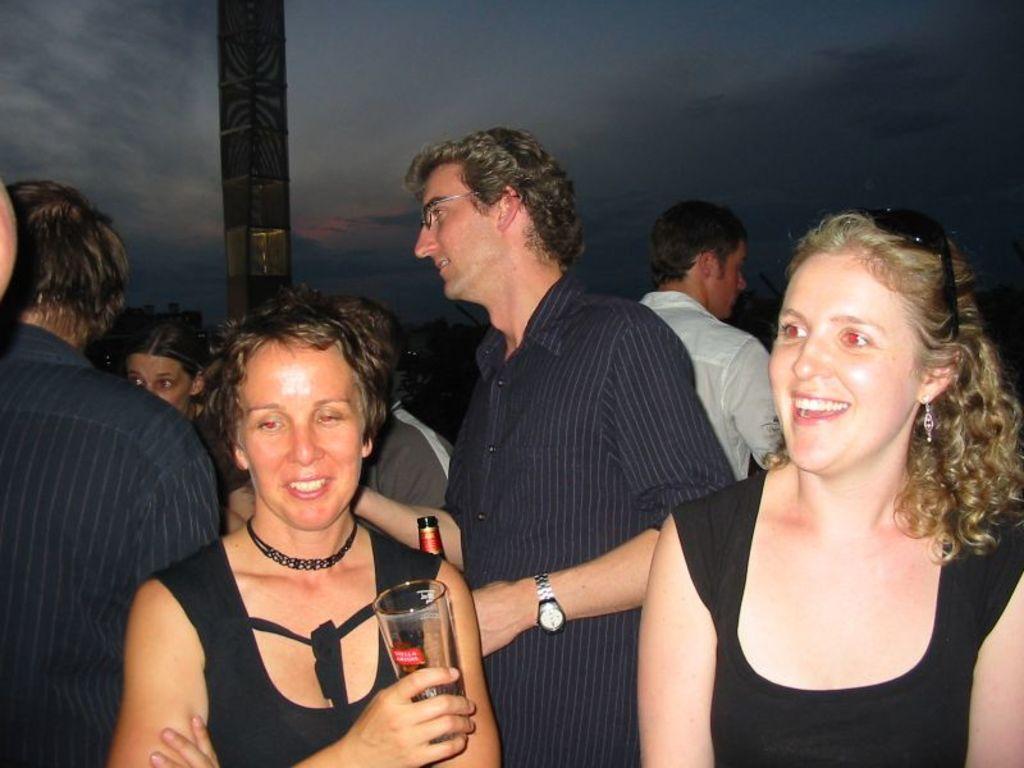How would you summarize this image in a sentence or two? In this image we can see a group of people standing. One woman wearing black dress is holding a glass in her hand. one person wearing spectacles is holding a bottle in his hand. In the background, we can see a person wearing a white shirt, a pole and the sky. 